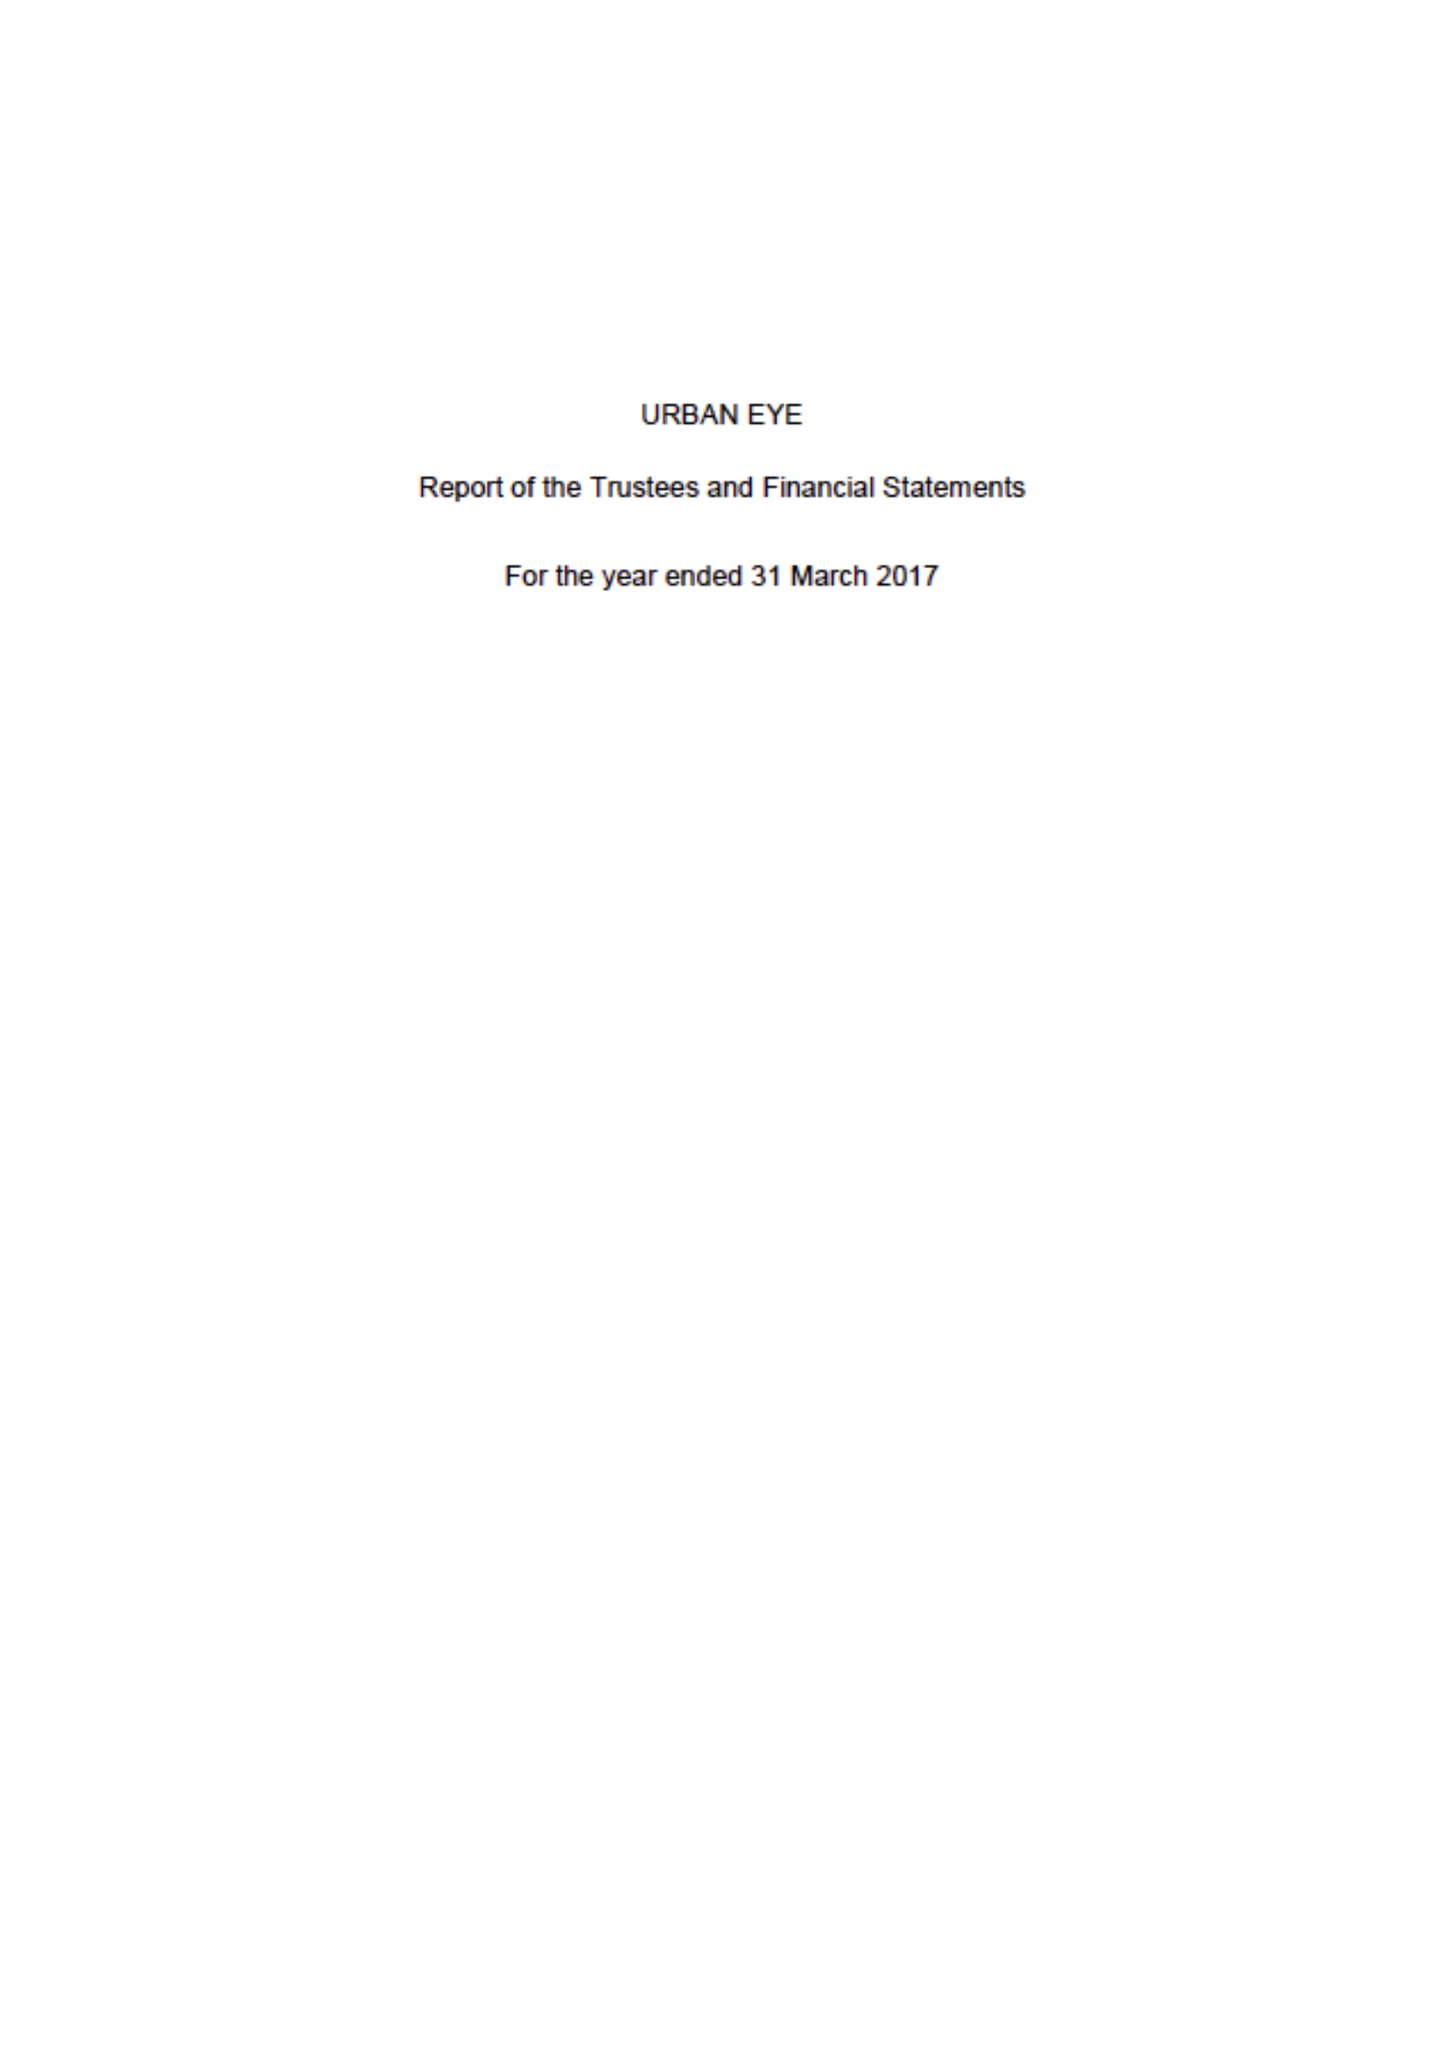What is the value for the address__postcode?
Answer the question using a single word or phrase. W11 4AT 